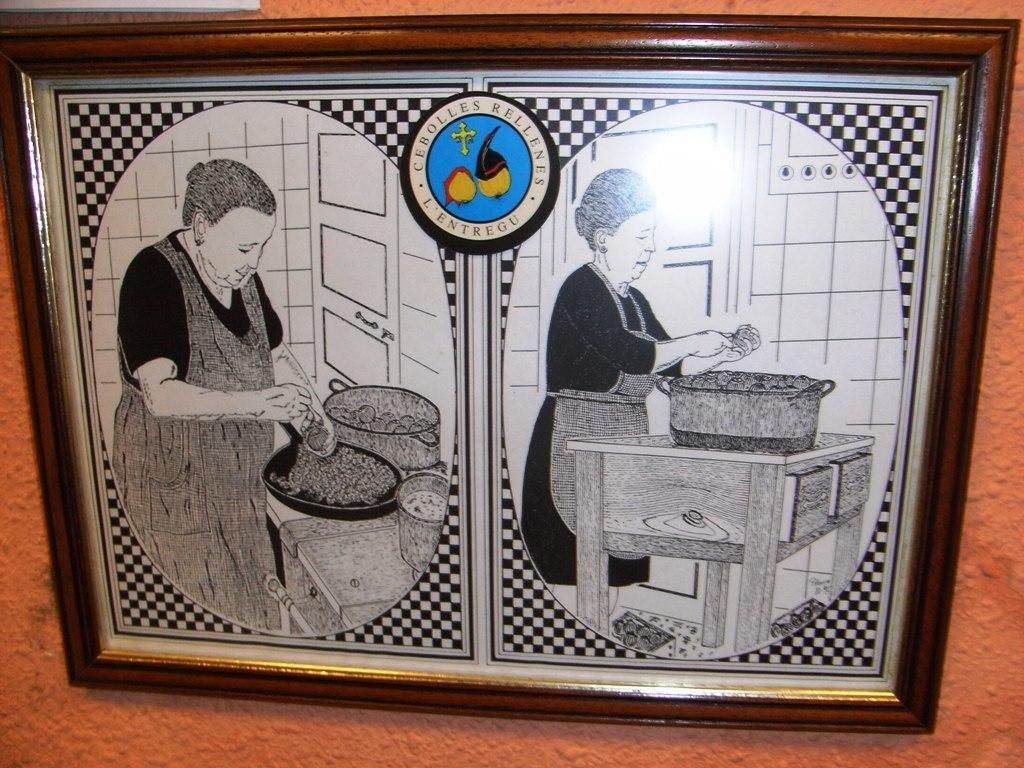What object is present in the image that holds a picture? There is a photo frame in the image. What can be seen inside the photo frame? The photo frame contains a picture of a woman. What is the woman wearing in the picture? The woman is wearing a black dress in the picture. What activity is the woman engaged in within the picture? The woman is cooking in the picture. What color is the wall on which the photo frame is placed? The photo frame is placed on a red color wall. What type of basket is hanging on the wall next to the photo frame? There is no basket present in the image; only the photo frame and the red color wall are visible. 